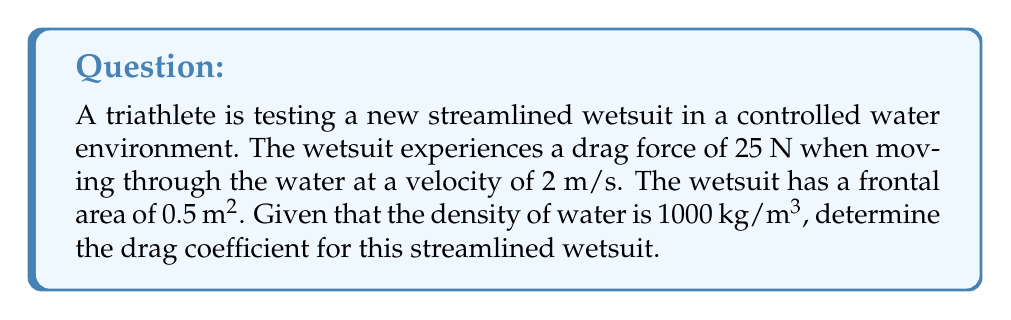Can you answer this question? To solve this problem, we'll use the drag equation:

$$F_d = \frac{1}{2} \rho v^2 C_d A$$

Where:
$F_d$ = Drag force (N)
$\rho$ = Fluid density (kg/m³)
$v$ = Velocity (m/s)
$C_d$ = Drag coefficient (dimensionless)
$A$ = Frontal area (m²)

We know:
$F_d = 25$ N
$\rho = 1000$ kg/m³
$v = 2$ m/s
$A = 0.5$ m²

Let's solve for $C_d$:

1) Rearrange the equation to isolate $C_d$:
   $$C_d = \frac{2F_d}{\rho v^2 A}$$

2) Substitute the known values:
   $$C_d = \frac{2(25)}{1000(2^2)(0.5)}$$

3) Calculate:
   $$C_d = \frac{50}{2000} = 0.025$$

Therefore, the drag coefficient for this streamlined wetsuit is 0.025.
Answer: $C_d = 0.025$ 